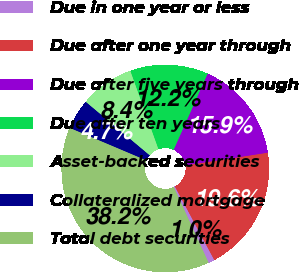Convert chart. <chart><loc_0><loc_0><loc_500><loc_500><pie_chart><fcel>Due in one year or less<fcel>Due after one year through<fcel>Due after five years through<fcel>Due after ten years<fcel>Asset-backed securities<fcel>Collateralized mortgage<fcel>Total debt securities<nl><fcel>0.98%<fcel>19.61%<fcel>15.88%<fcel>12.16%<fcel>8.43%<fcel>4.71%<fcel>38.23%<nl></chart> 